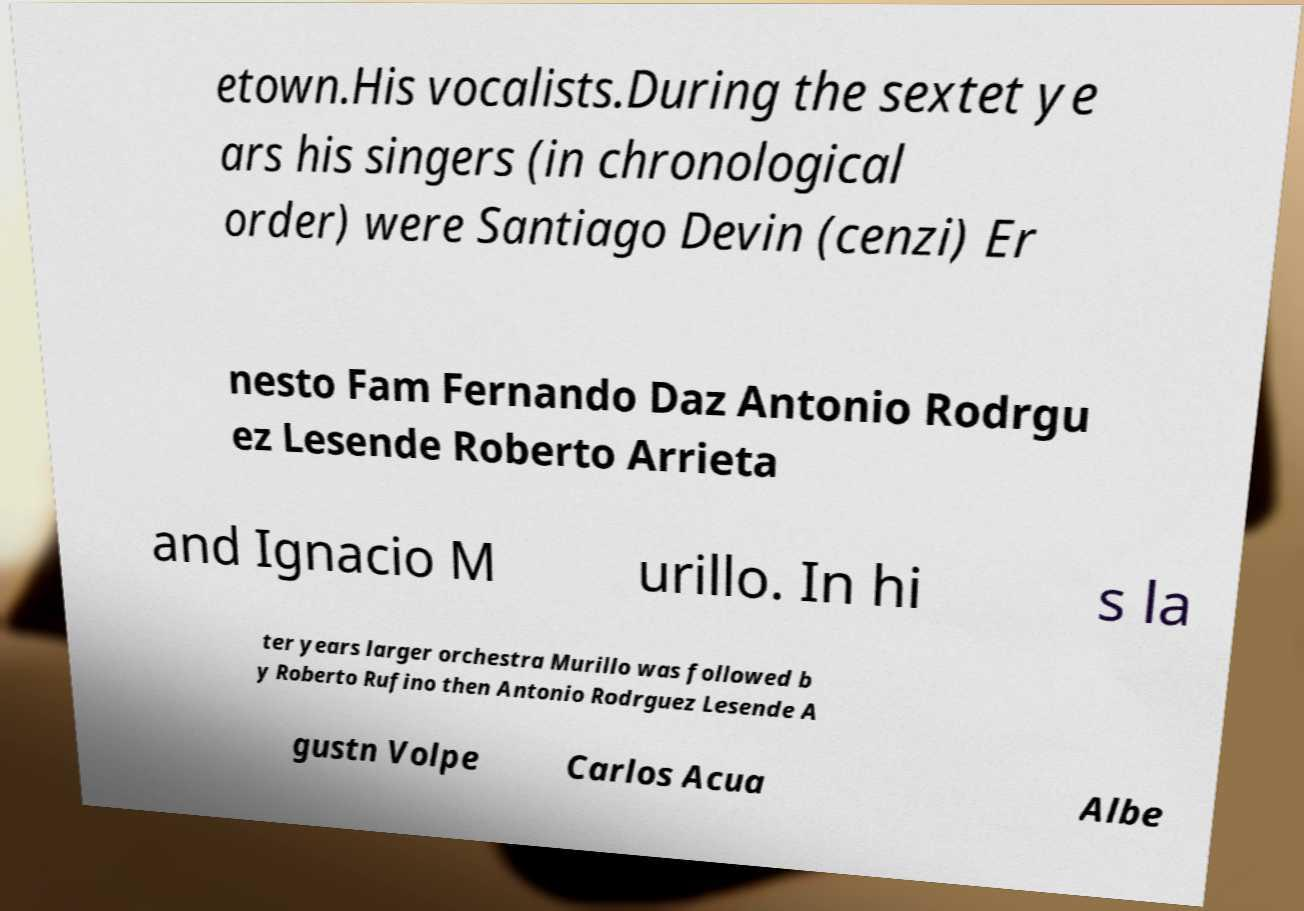Can you read and provide the text displayed in the image?This photo seems to have some interesting text. Can you extract and type it out for me? etown.His vocalists.During the sextet ye ars his singers (in chronological order) were Santiago Devin (cenzi) Er nesto Fam Fernando Daz Antonio Rodrgu ez Lesende Roberto Arrieta and Ignacio M urillo. In hi s la ter years larger orchestra Murillo was followed b y Roberto Rufino then Antonio Rodrguez Lesende A gustn Volpe Carlos Acua Albe 